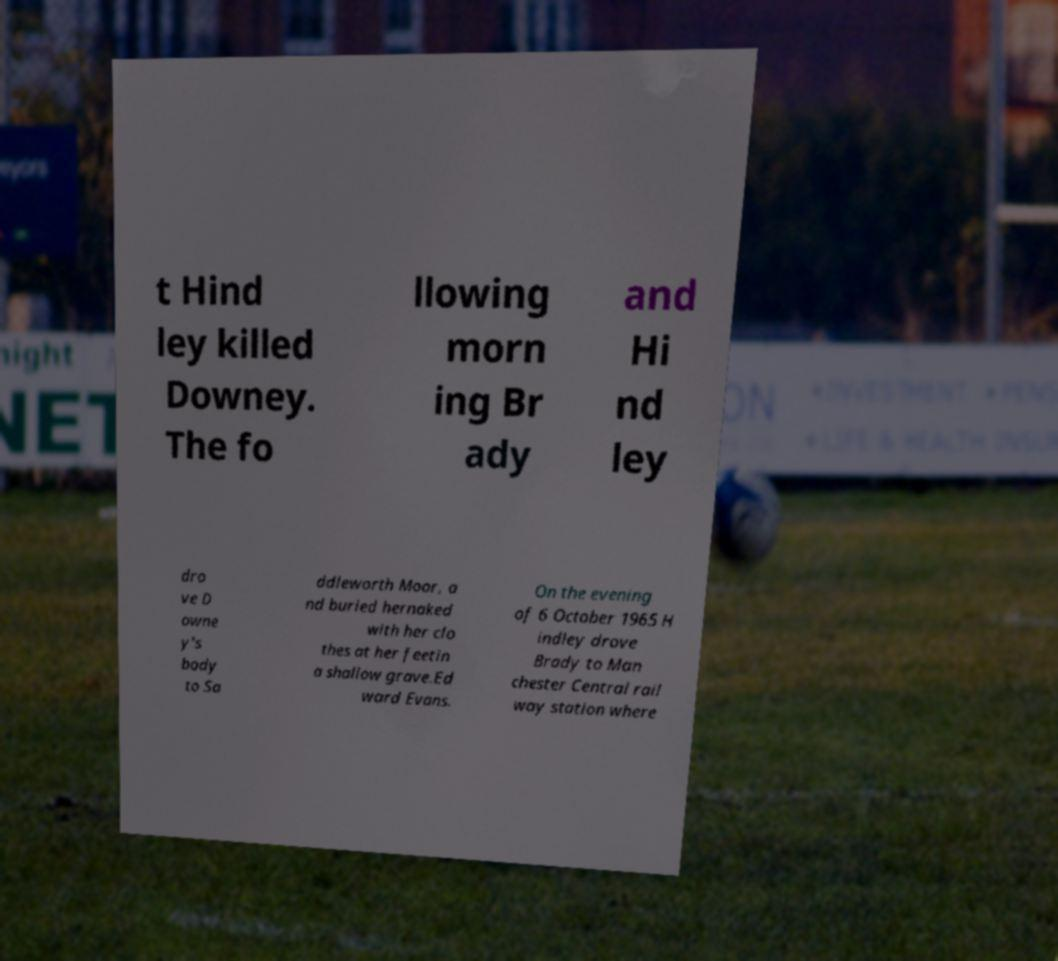For documentation purposes, I need the text within this image transcribed. Could you provide that? t Hind ley killed Downey. The fo llowing morn ing Br ady and Hi nd ley dro ve D owne y's body to Sa ddleworth Moor, a nd buried hernaked with her clo thes at her feetin a shallow grave.Ed ward Evans. On the evening of 6 October 1965 H indley drove Brady to Man chester Central rail way station where 